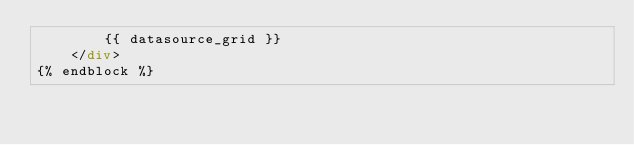<code> <loc_0><loc_0><loc_500><loc_500><_HTML_>        {{ datasource_grid }}
    </div>
{% endblock %}
</code> 